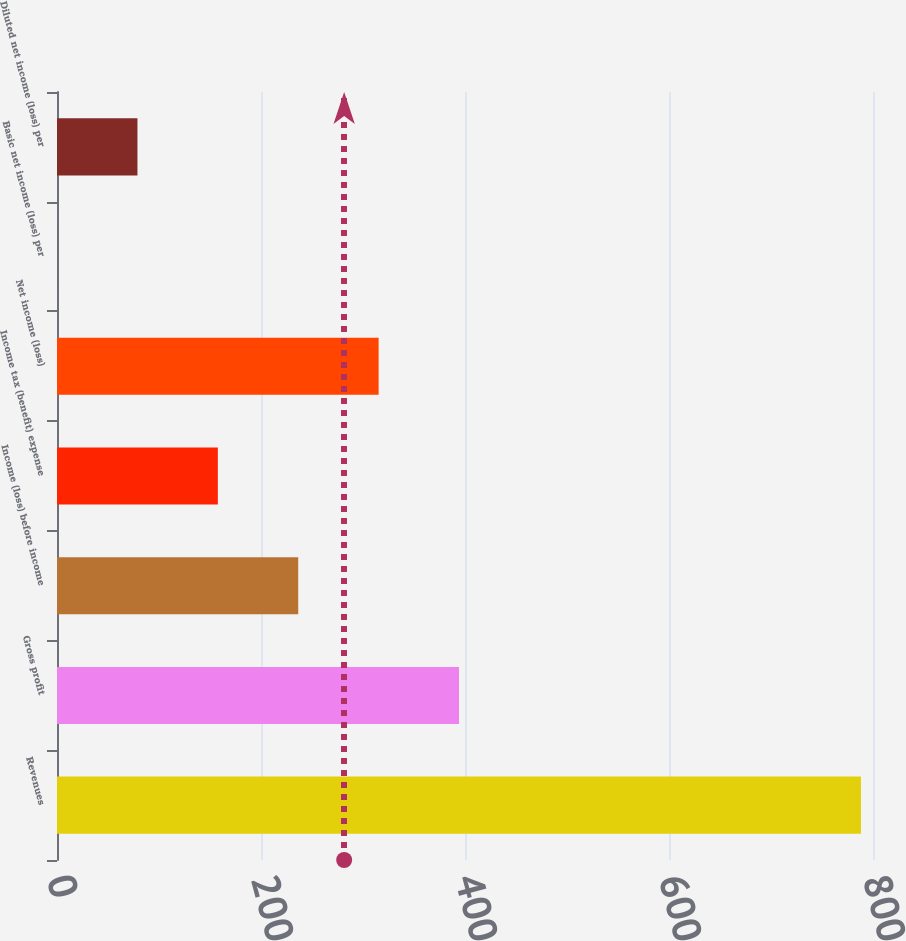Convert chart to OTSL. <chart><loc_0><loc_0><loc_500><loc_500><bar_chart><fcel>Revenues<fcel>Gross profit<fcel>Income (loss) before income<fcel>Income tax (benefit) expense<fcel>Net income (loss)<fcel>Basic net income (loss) per<fcel>Diluted net income (loss) per<nl><fcel>788.2<fcel>394.11<fcel>236.49<fcel>157.68<fcel>315.3<fcel>0.06<fcel>78.87<nl></chart> 